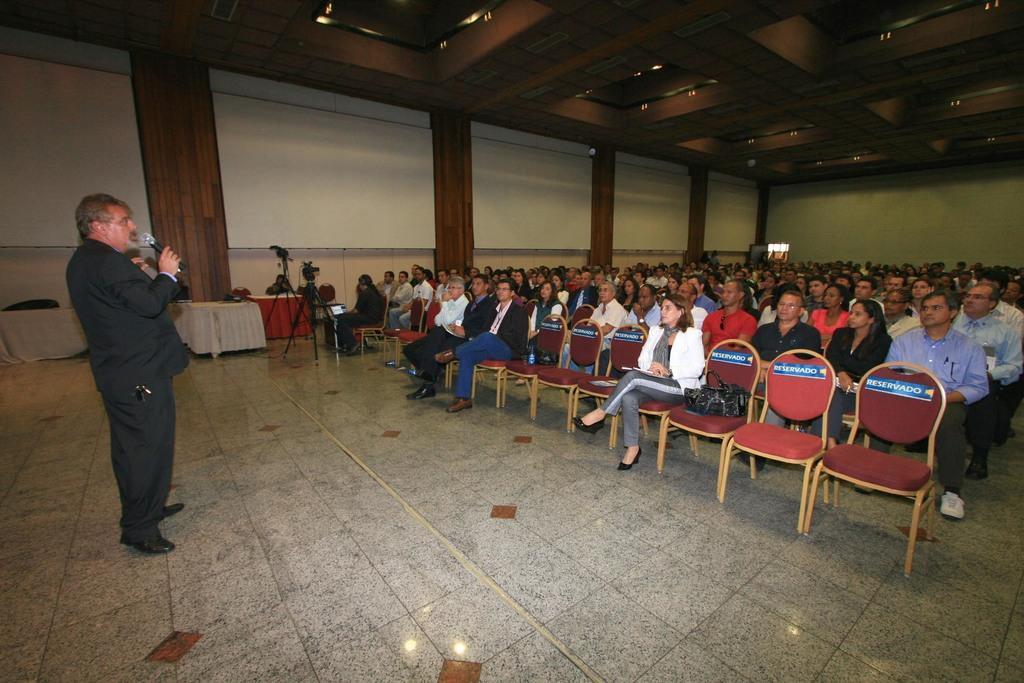In one or two sentences, can you explain what this image depicts? People are sitting on the chair,person is standing carrying mike,here there is table,white color wall. 